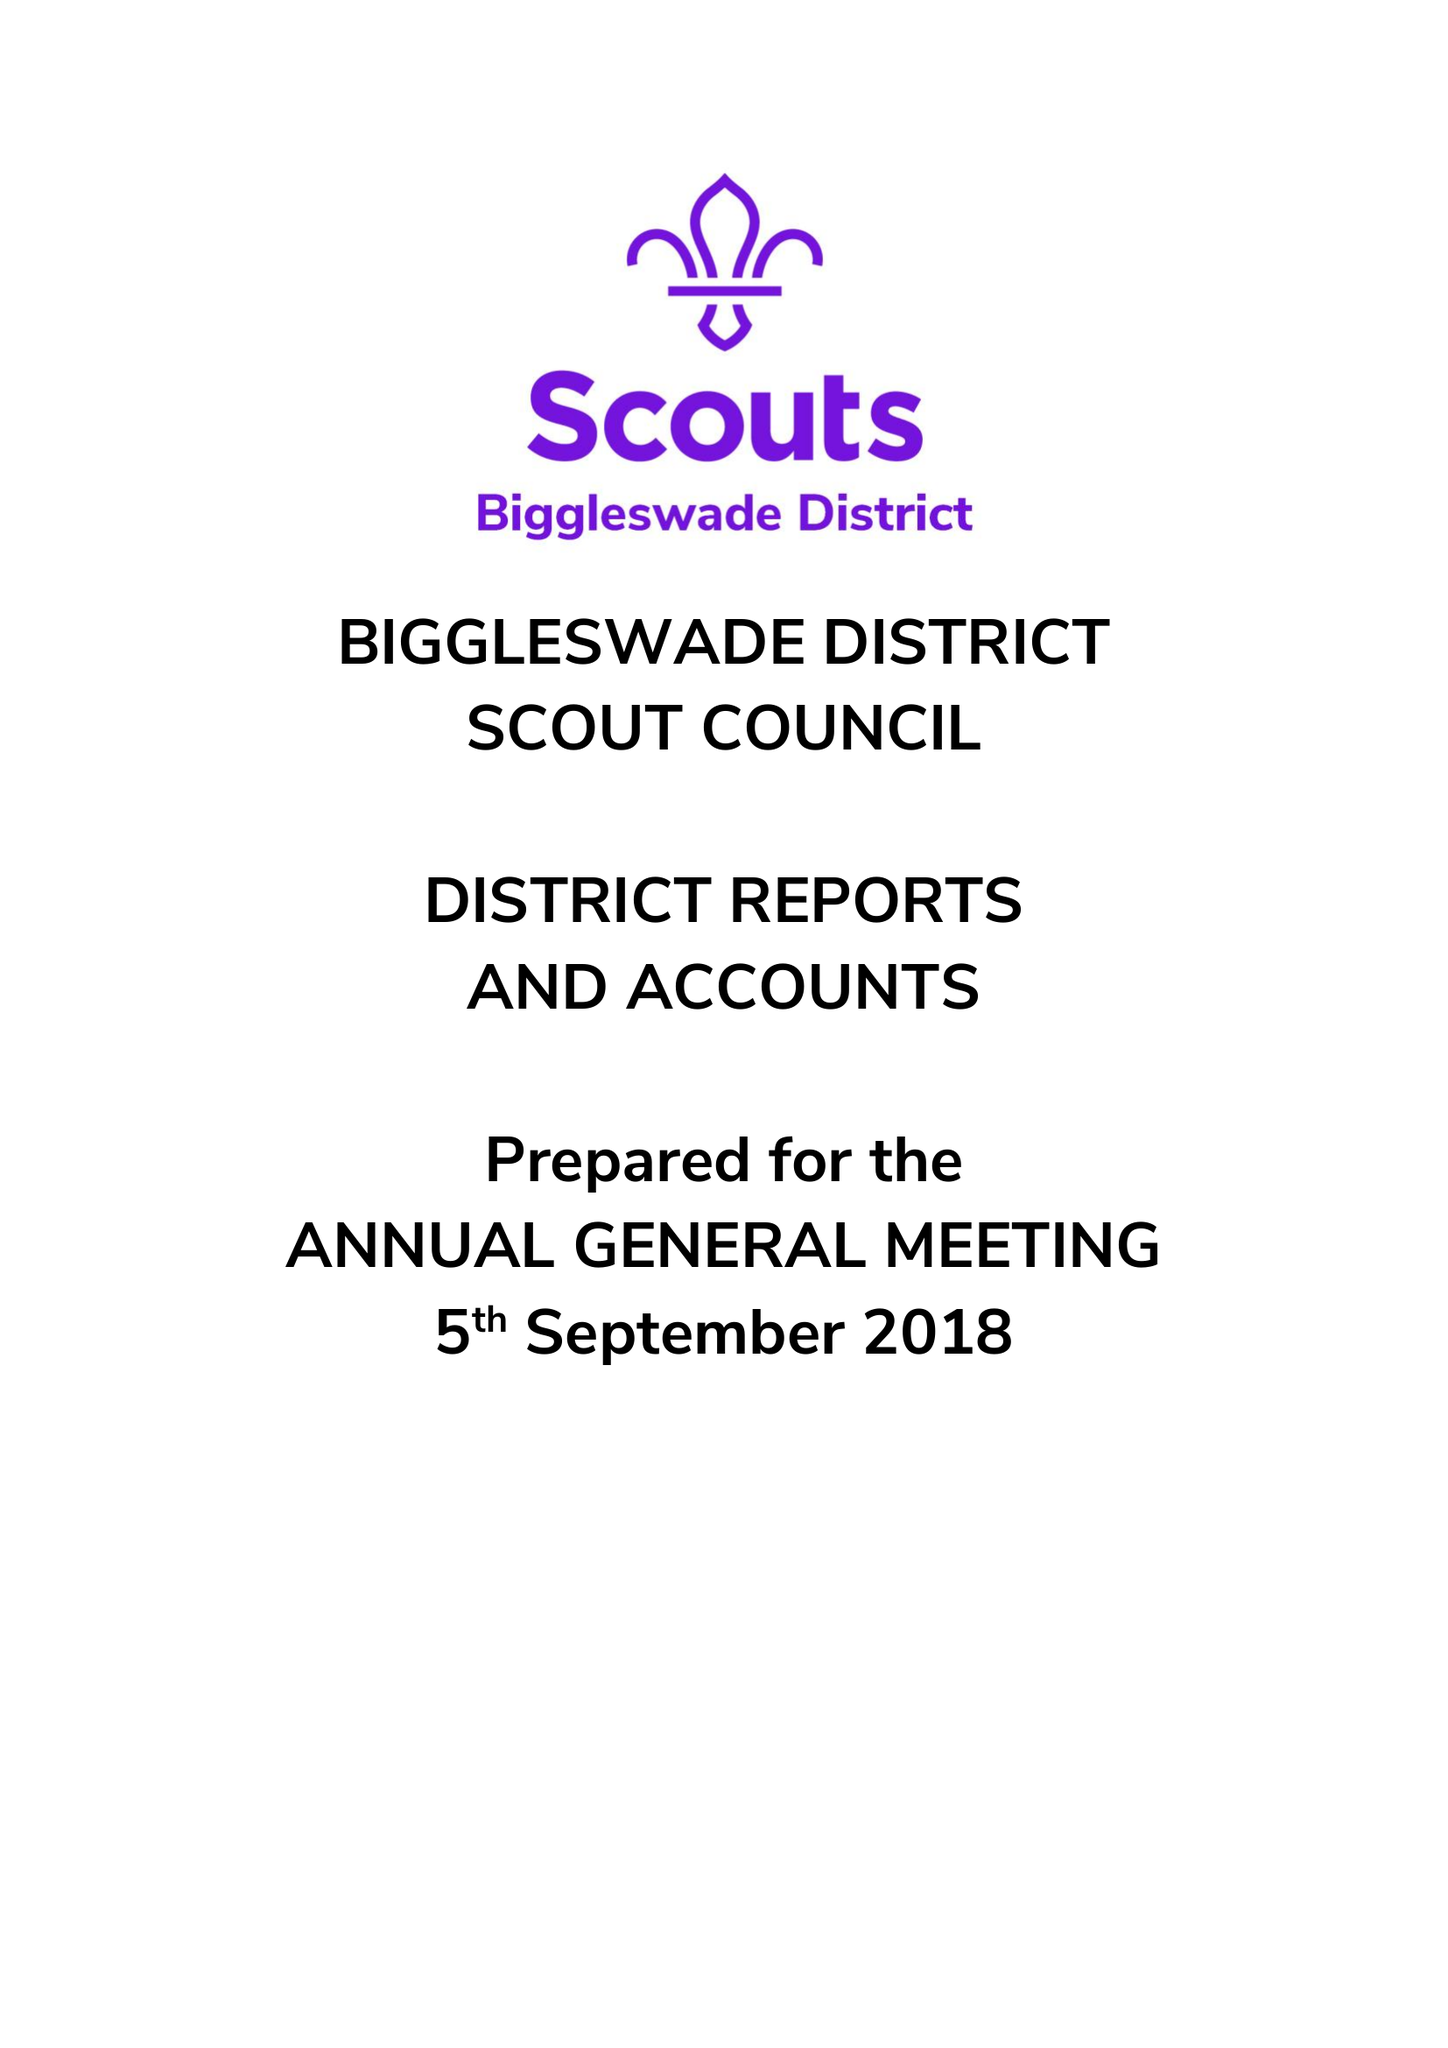What is the value for the address__street_line?
Answer the question using a single word or phrase. 20 SOUNDY PADDOCK 